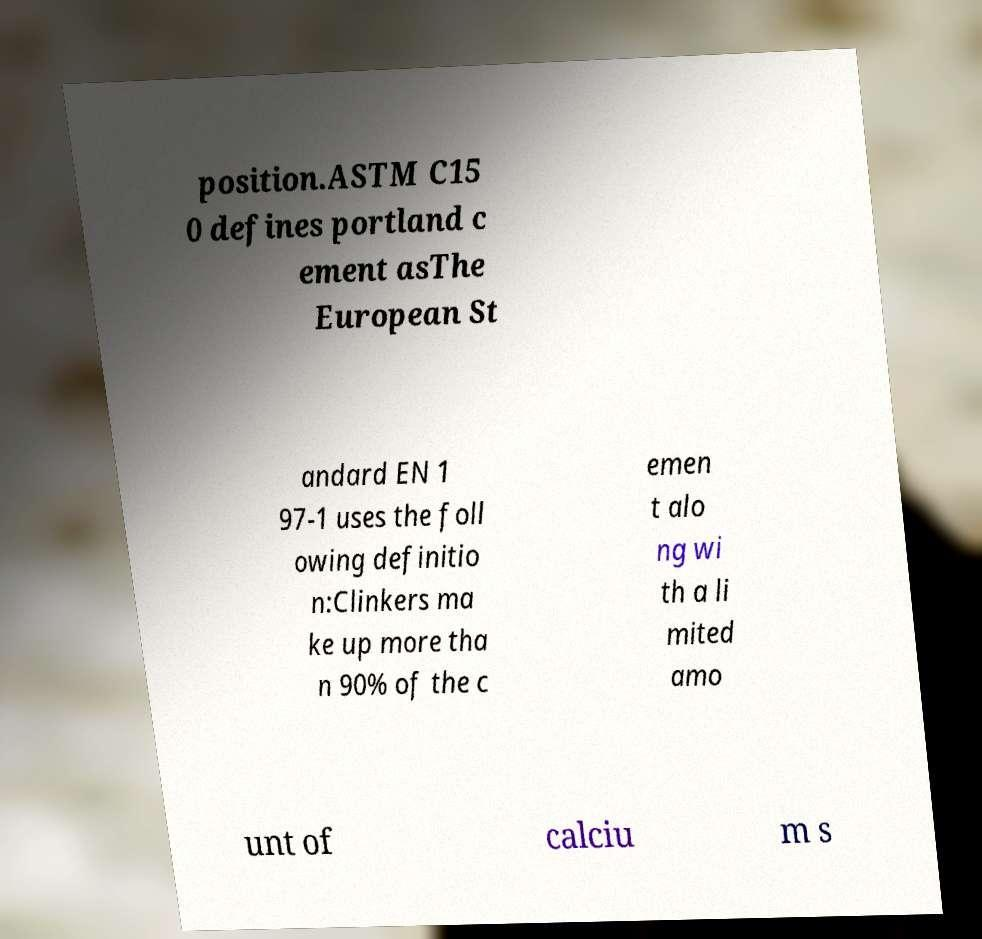Could you assist in decoding the text presented in this image and type it out clearly? position.ASTM C15 0 defines portland c ement asThe European St andard EN 1 97-1 uses the foll owing definitio n:Clinkers ma ke up more tha n 90% of the c emen t alo ng wi th a li mited amo unt of calciu m s 